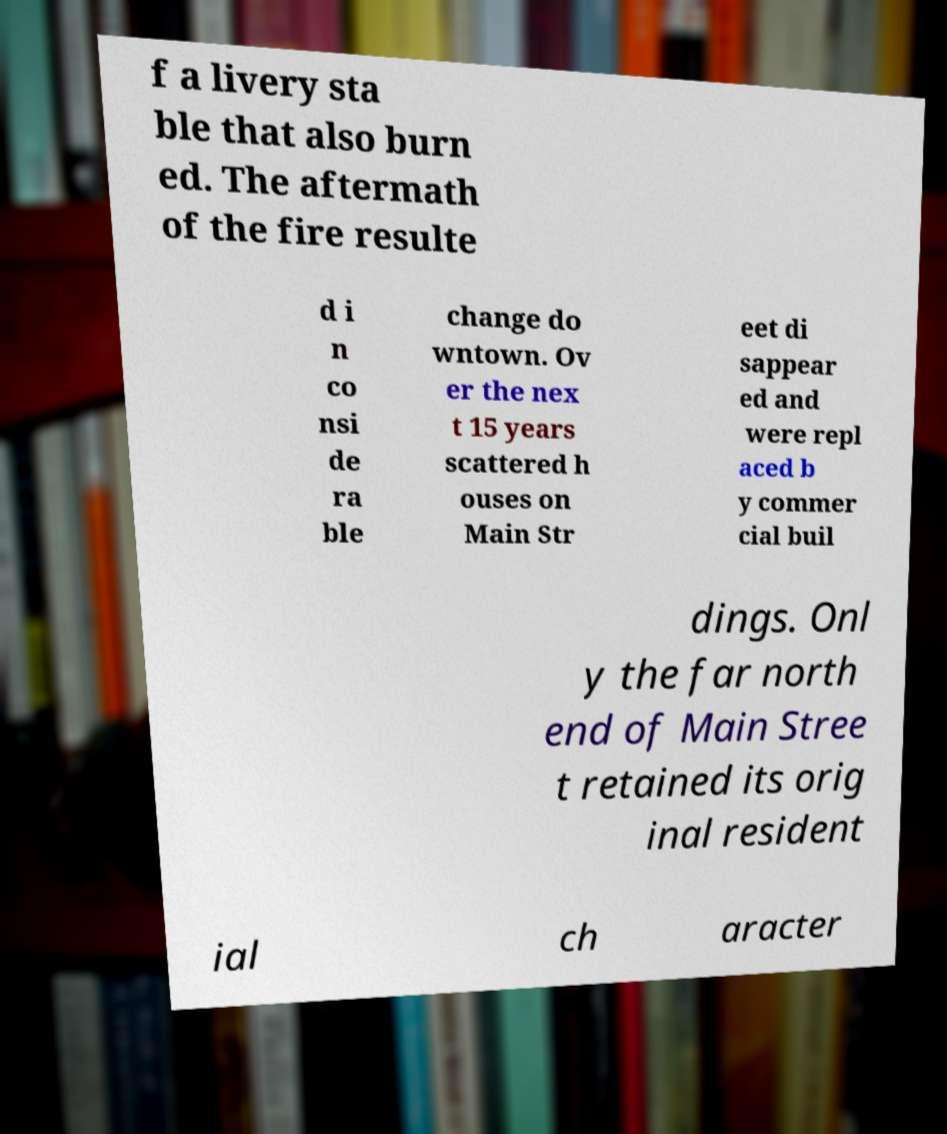Could you extract and type out the text from this image? f a livery sta ble that also burn ed. The aftermath of the fire resulte d i n co nsi de ra ble change do wntown. Ov er the nex t 15 years scattered h ouses on Main Str eet di sappear ed and were repl aced b y commer cial buil dings. Onl y the far north end of Main Stree t retained its orig inal resident ial ch aracter 